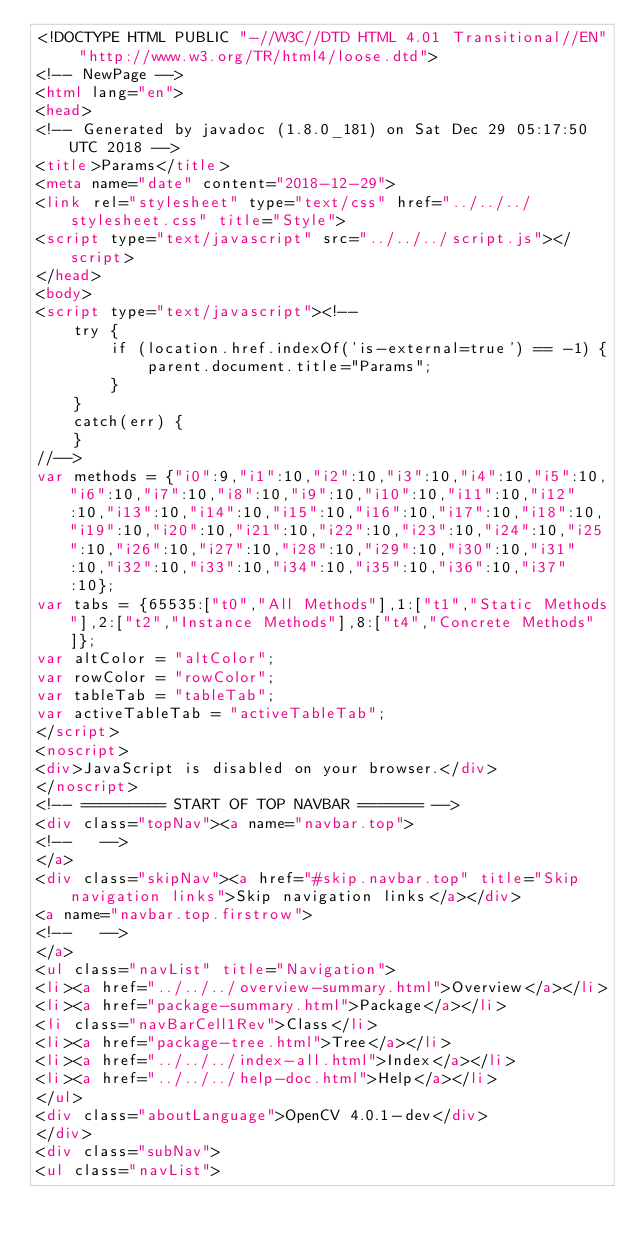<code> <loc_0><loc_0><loc_500><loc_500><_HTML_><!DOCTYPE HTML PUBLIC "-//W3C//DTD HTML 4.01 Transitional//EN" "http://www.w3.org/TR/html4/loose.dtd">
<!-- NewPage -->
<html lang="en">
<head>
<!-- Generated by javadoc (1.8.0_181) on Sat Dec 29 05:17:50 UTC 2018 -->
<title>Params</title>
<meta name="date" content="2018-12-29">
<link rel="stylesheet" type="text/css" href="../../../stylesheet.css" title="Style">
<script type="text/javascript" src="../../../script.js"></script>
</head>
<body>
<script type="text/javascript"><!--
    try {
        if (location.href.indexOf('is-external=true') == -1) {
            parent.document.title="Params";
        }
    }
    catch(err) {
    }
//-->
var methods = {"i0":9,"i1":10,"i2":10,"i3":10,"i4":10,"i5":10,"i6":10,"i7":10,"i8":10,"i9":10,"i10":10,"i11":10,"i12":10,"i13":10,"i14":10,"i15":10,"i16":10,"i17":10,"i18":10,"i19":10,"i20":10,"i21":10,"i22":10,"i23":10,"i24":10,"i25":10,"i26":10,"i27":10,"i28":10,"i29":10,"i30":10,"i31":10,"i32":10,"i33":10,"i34":10,"i35":10,"i36":10,"i37":10};
var tabs = {65535:["t0","All Methods"],1:["t1","Static Methods"],2:["t2","Instance Methods"],8:["t4","Concrete Methods"]};
var altColor = "altColor";
var rowColor = "rowColor";
var tableTab = "tableTab";
var activeTableTab = "activeTableTab";
</script>
<noscript>
<div>JavaScript is disabled on your browser.</div>
</noscript>
<!-- ========= START OF TOP NAVBAR ======= -->
<div class="topNav"><a name="navbar.top">
<!--   -->
</a>
<div class="skipNav"><a href="#skip.navbar.top" title="Skip navigation links">Skip navigation links</a></div>
<a name="navbar.top.firstrow">
<!--   -->
</a>
<ul class="navList" title="Navigation">
<li><a href="../../../overview-summary.html">Overview</a></li>
<li><a href="package-summary.html">Package</a></li>
<li class="navBarCell1Rev">Class</li>
<li><a href="package-tree.html">Tree</a></li>
<li><a href="../../../index-all.html">Index</a></li>
<li><a href="../../../help-doc.html">Help</a></li>
</ul>
<div class="aboutLanguage">OpenCV 4.0.1-dev</div>
</div>
<div class="subNav">
<ul class="navList"></code> 